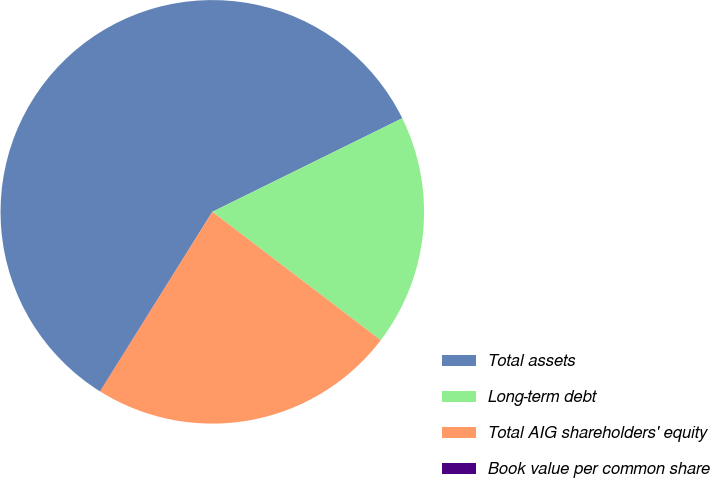<chart> <loc_0><loc_0><loc_500><loc_500><pie_chart><fcel>Total assets<fcel>Long-term debt<fcel>Total AIG shareholders' equity<fcel>Book value per common share<nl><fcel>58.81%<fcel>17.65%<fcel>23.53%<fcel>0.01%<nl></chart> 